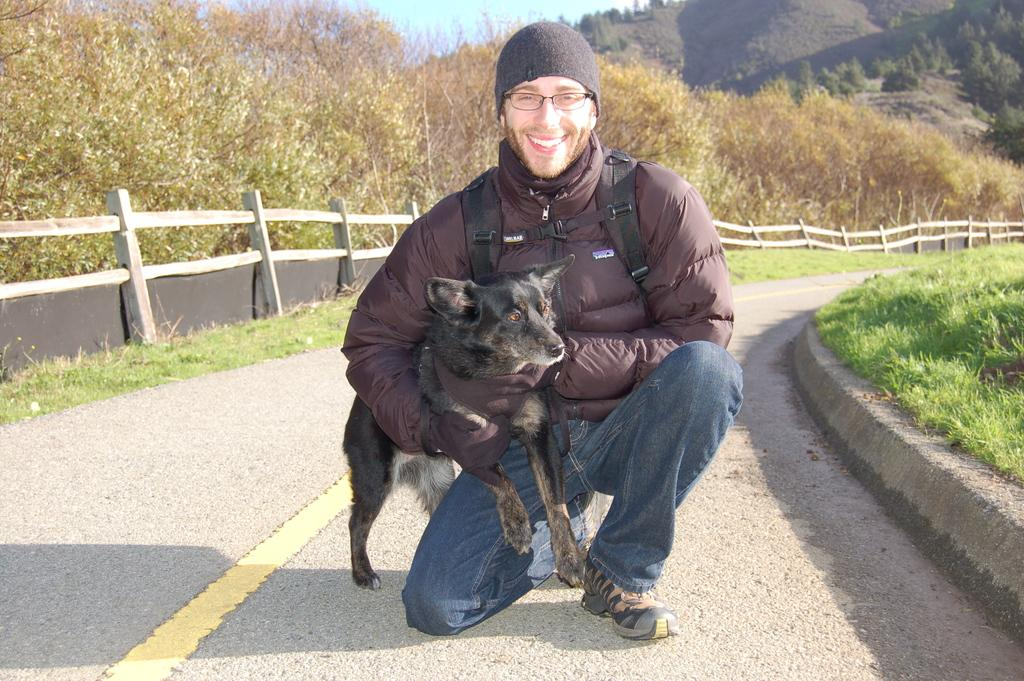Who is present in the image? There is a person in the image. Where is the person located? The person is on the road. What is the person holding? The person is holding a dog. What is the person's facial expression? The person is smiling. What items is the person wearing? The person is wearing a backpack and a cap. What can be seen in the background of the image? Plants are visible in the background of the image. How many dimes are visible on the sheet in the image? There are no dimes or sheets present in the image. 